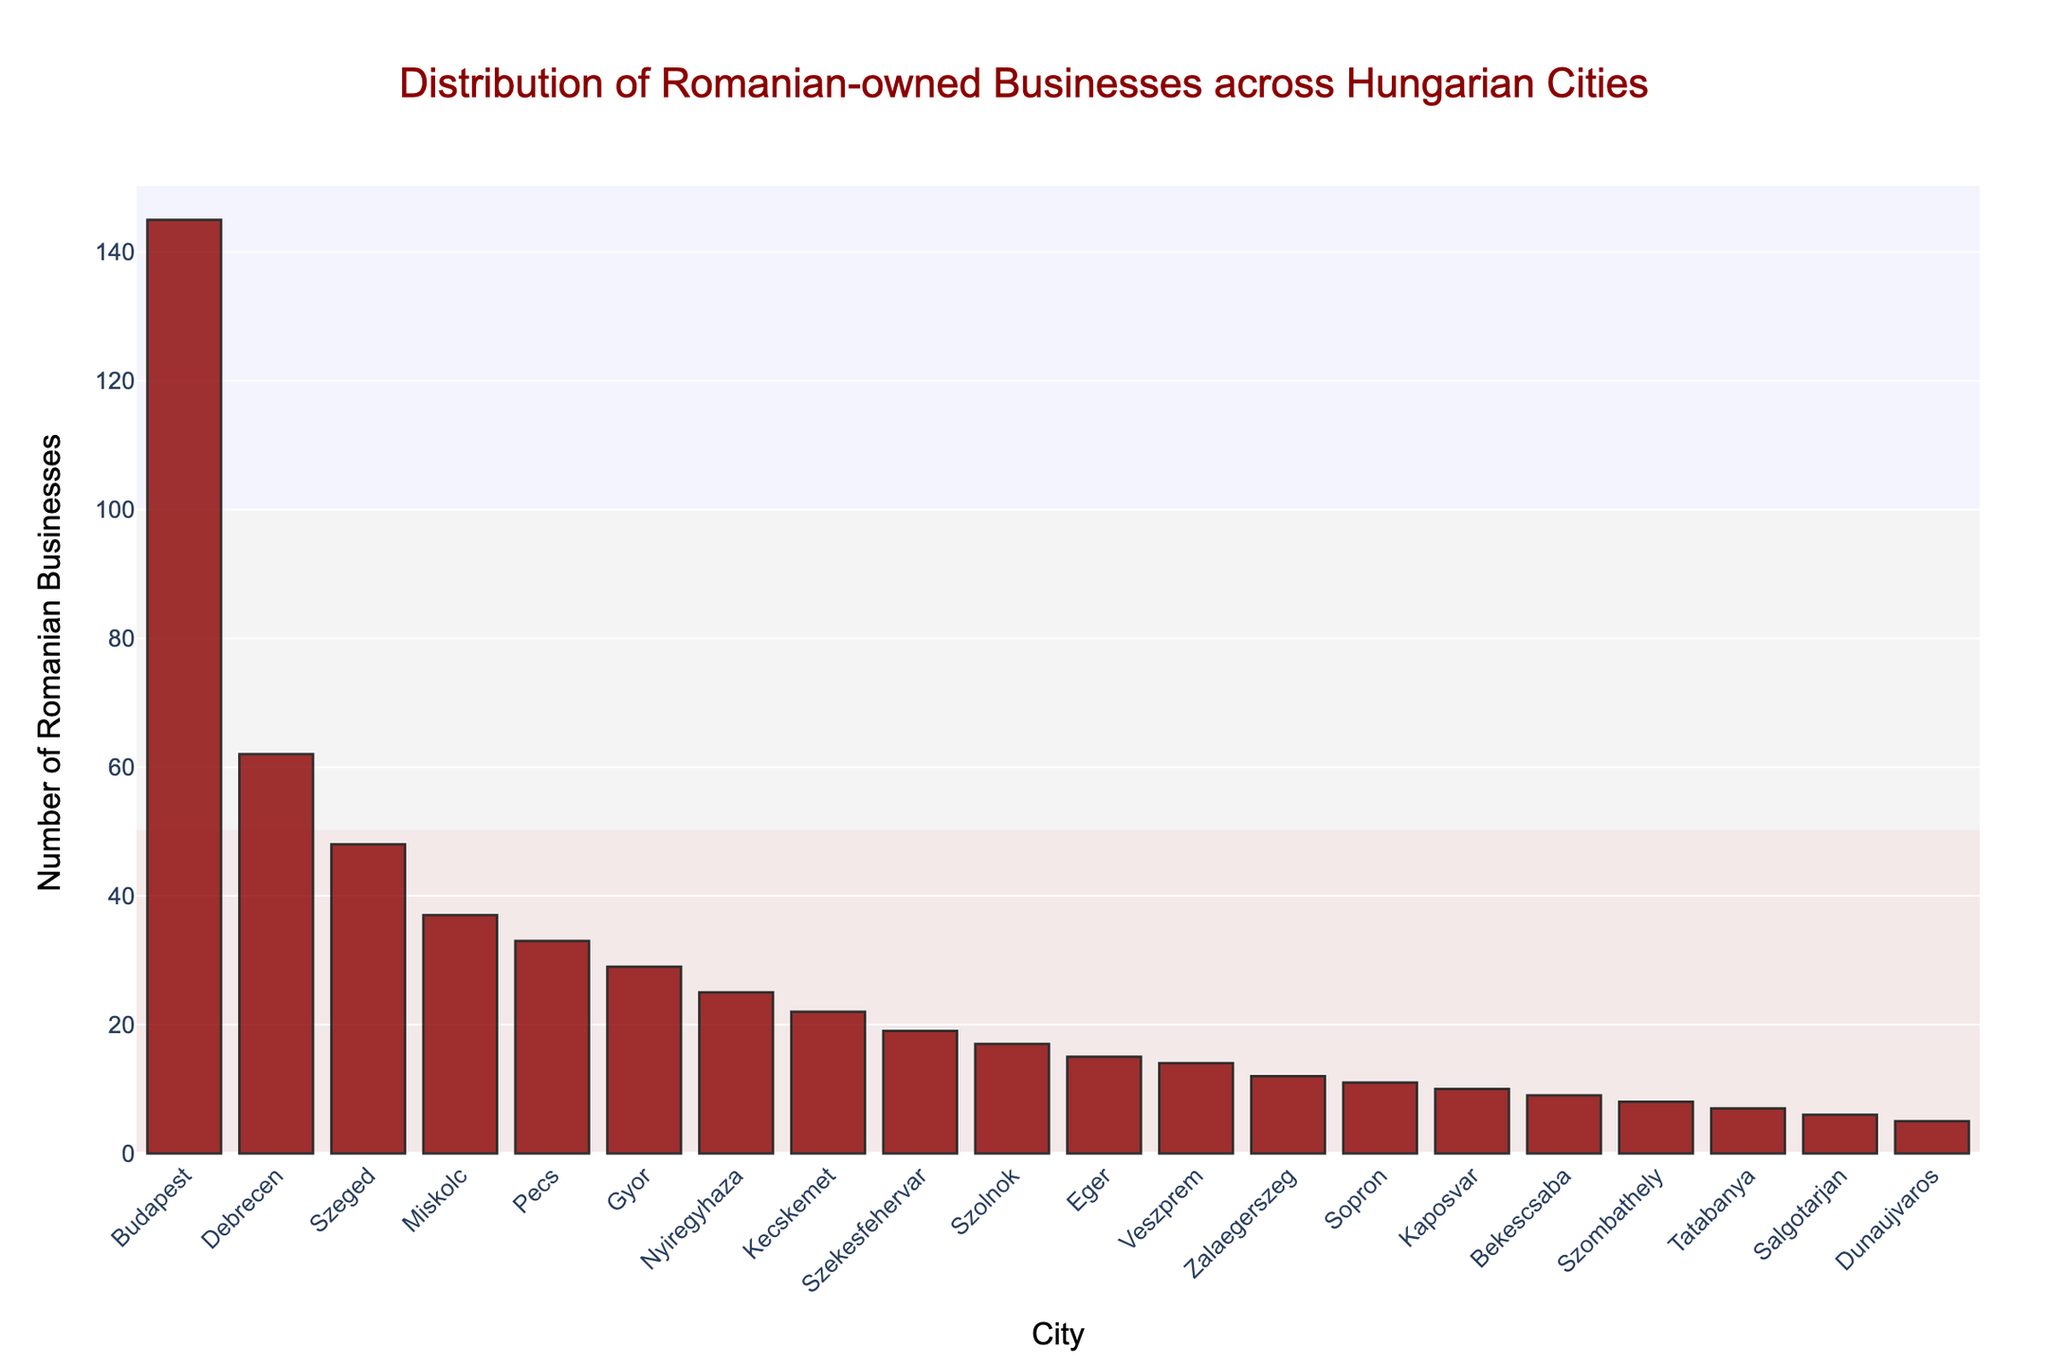What's the city with the highest number of Romanian-owned businesses? The figure shows a bar for each city, with the height representing the number of businesses. The tallest bar corresponds to Budapest.
Answer: Budapest How many Romanian-owned businesses are there in Debrecen? Locate the bar labeled Debrecen to find its height, which represents the number of businesses. The bar for Debrecen is at 62.
Answer: 62 Which city has fewer Romanian-owned businesses: Szeged or Gyor? Compare the heights of the bars for Szeged and Gyor. Szeged's bar is taller than Gyor's, indicating Szeged has more businesses.
Answer: Gyor What is the sum of Romanian-owned businesses in Pecs and Miskolc? Find the heights of the bars for Pecs and Miskolc, which are 33 and 37 respectively. Add them together: 33 + 37 = 70.
Answer: 70 What is the difference in the number of Romanian-owned businesses between Budapest and Dunaujvaros? Find the heights of the bars for Budapest and Dunaujvaros, which are 145 and 5 respectively. Subtract Dunaujvaros from Budapest: 145 - 5 = 140.
Answer: 140 Which city has slightly more Romanian-owned businesses: Kaposvar or Bekescsaba? Compare the heights of the bars for Kaposvar and Bekescsaba. Kaposvar has 10 businesses, slightly more than Bekescsaba’s 9.
Answer: Kaposvar Is the number of Romanian-owned businesses in Kecskemet greater than or equal to those in Nyiregyhaza? Compare the heights of the bars for Kecskemet and Nyiregyhaza. Kecskemet has 22 businesses, which is less than Nyiregyhaza's 25.
Answer: No What's the average number of Romanian-owned businesses in the three cities with the fewest businesses? Identify the cities with the fewest businesses: Dunaujvaros (5), Salgotarjan (6), and Tatabanya (7). Calculate the average: (5 + 6 + 7) / 3 = 6.
Answer: 6 Which city has more Romanian-owned businesses: Szekesfehervar or Szekesfehervar? References to the same city imply equal businesses. As Szekesfehervar has 19 businesses, there is no difference.
Answer: Equal Are there more Romanian-owned businesses in Szombathely or in the combined cities of Nyiregyhaza and Eger? Szombathely has 8 businesses. Nyiregyhaza and Eger have 25 and 15 respectively. Their combined total is 25 + 15 = 40, which is greater than 8.
Answer: Combined cities 